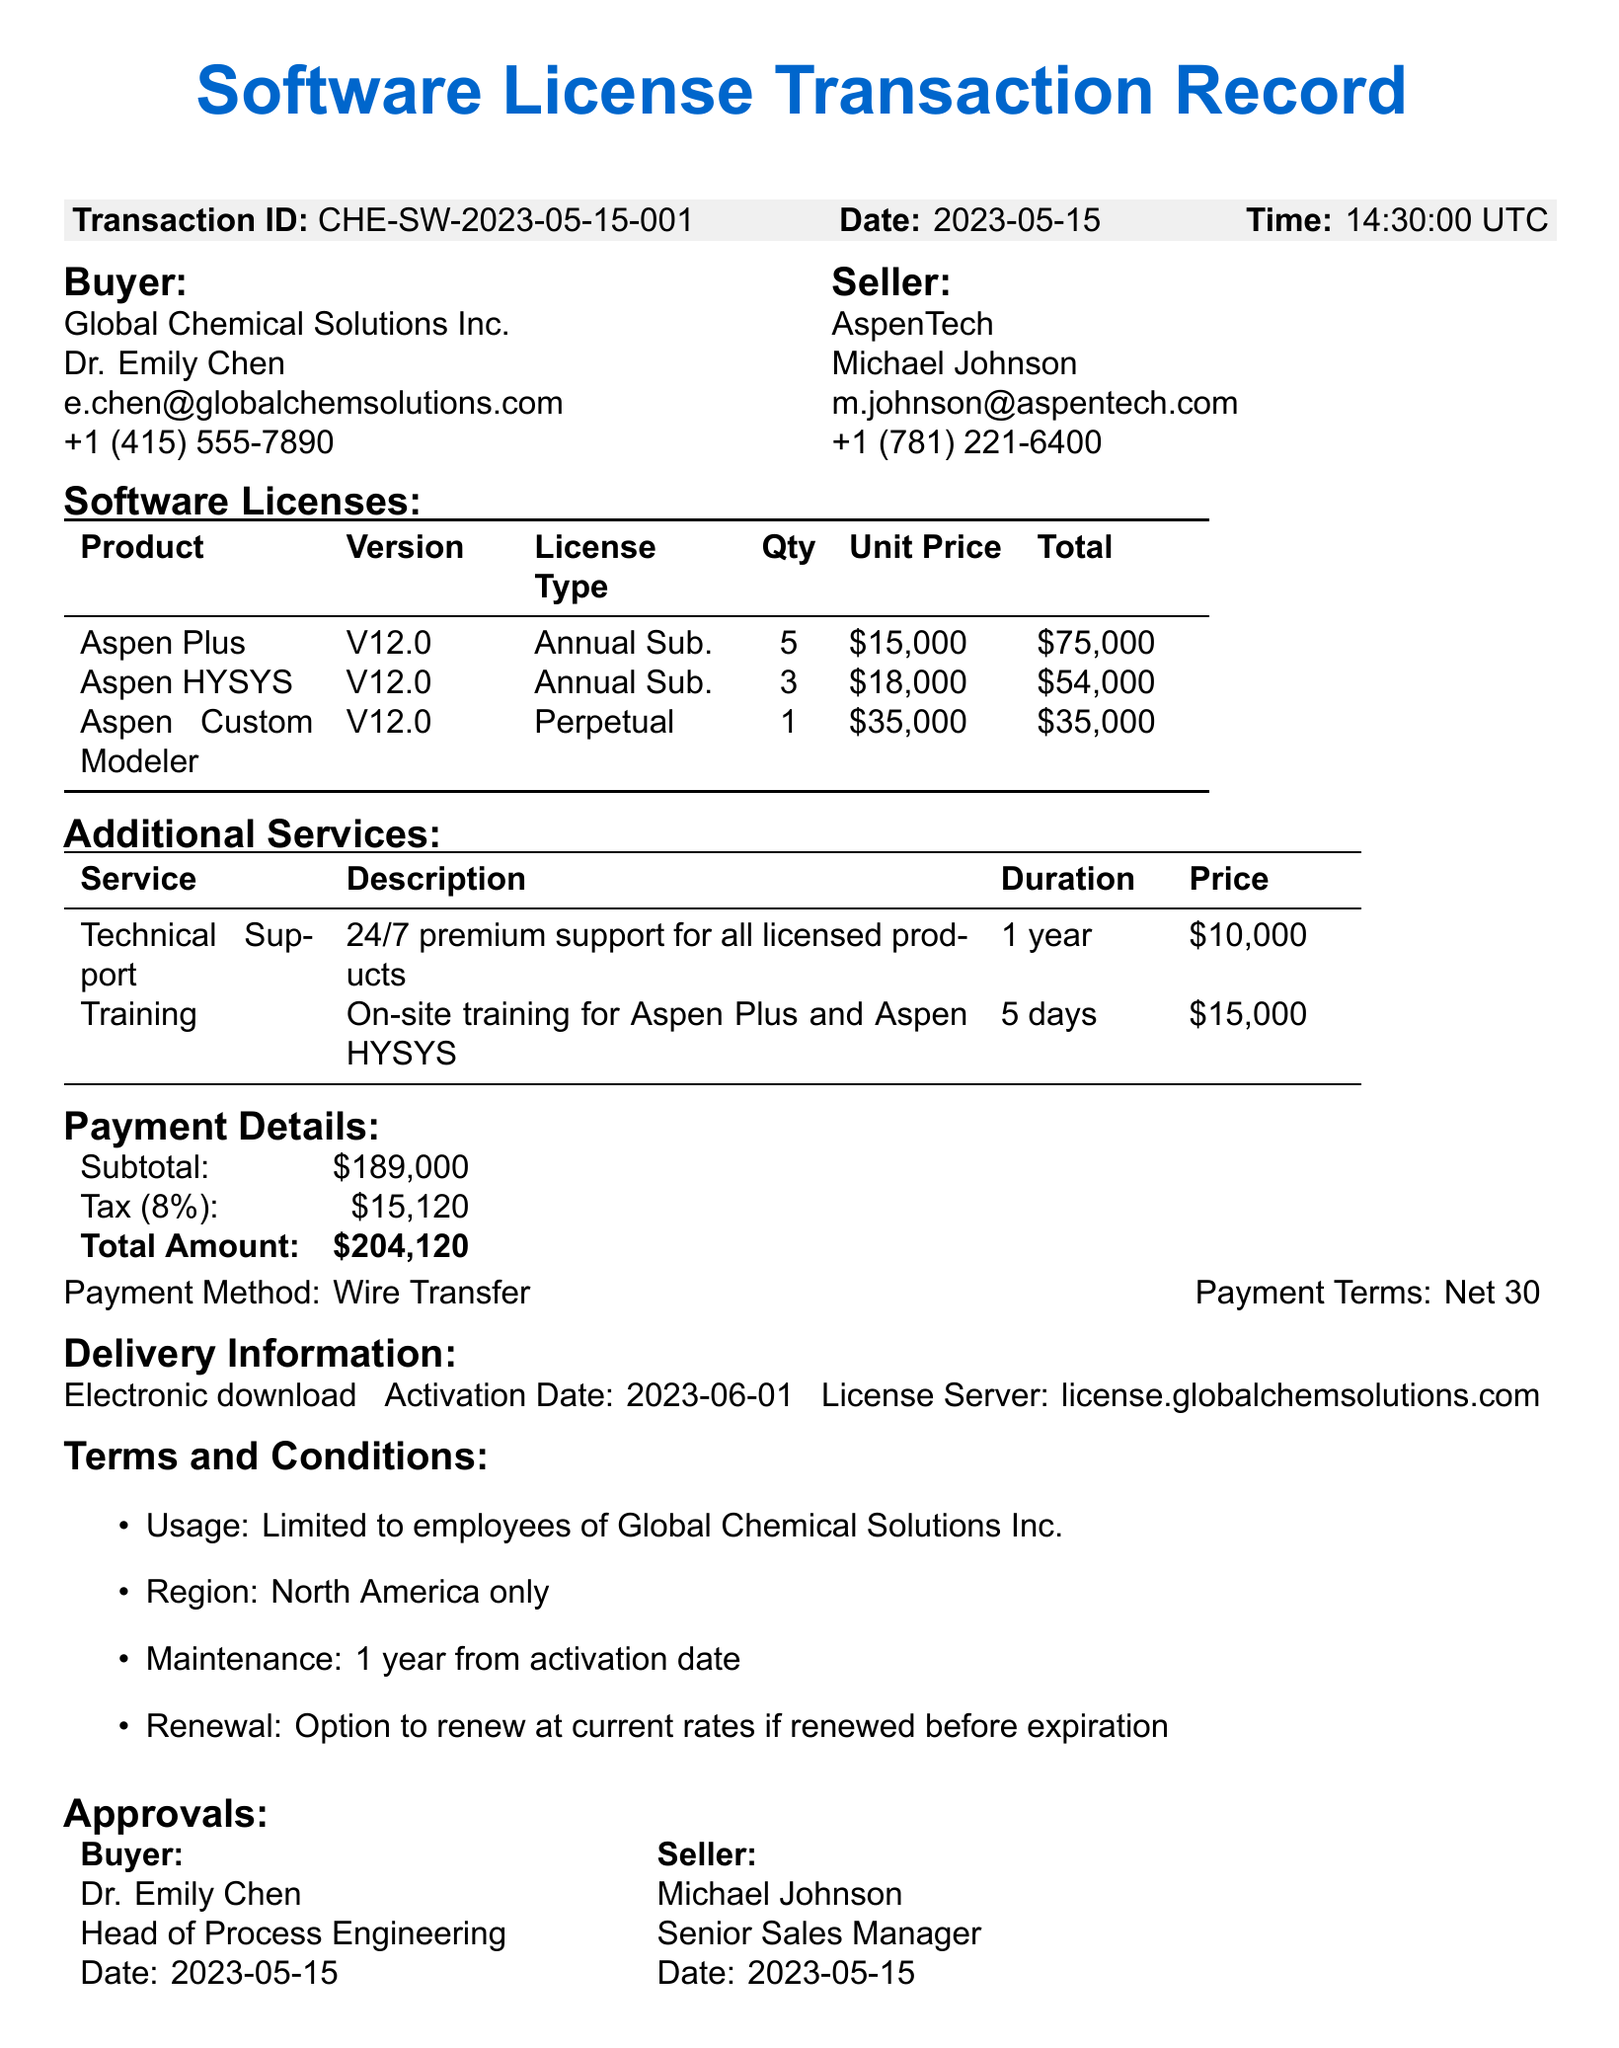What is the transaction ID? The transaction ID is a unique identifier for the transaction in the document.
Answer: CHE-SW-2023-05-15-001 Who is the buyer's contact person? The buyer's contact person is specified in the buyer information section of the document.
Answer: Dr. Emily Chen What is the total amount payable? The total amount is calculated as the sum of the subtotal and tax in the payment details section.
Answer: 204120 How many licenses of Aspen Plus were purchased? The quantity of Aspen Plus licenses is stated in the software licenses section of the document.
Answer: 5 What type of license is Aspen Custom Modeler? The license type for Aspen Custom Modeler is mentioned in the software licenses section, indicating whether it's annual or perpetual.
Answer: Perpetual What is the duration of the technical support service? The duration of the technical support service is outlined in the additional services section of the document.
Answer: 1 year What is the geographical limitation for using the licenses? The geographical limitation refers to where the licenses can be utilized, as specified in the terms and conditions.
Answer: North America region only What payment method was used for the transaction? The payment method describes how the payment was processed according to the payment details.
Answer: Wire Transfer Who approved the transaction from the seller's side? The seller's approver is listed in the approvals section of the document along with their title.
Answer: Michael Johnson 